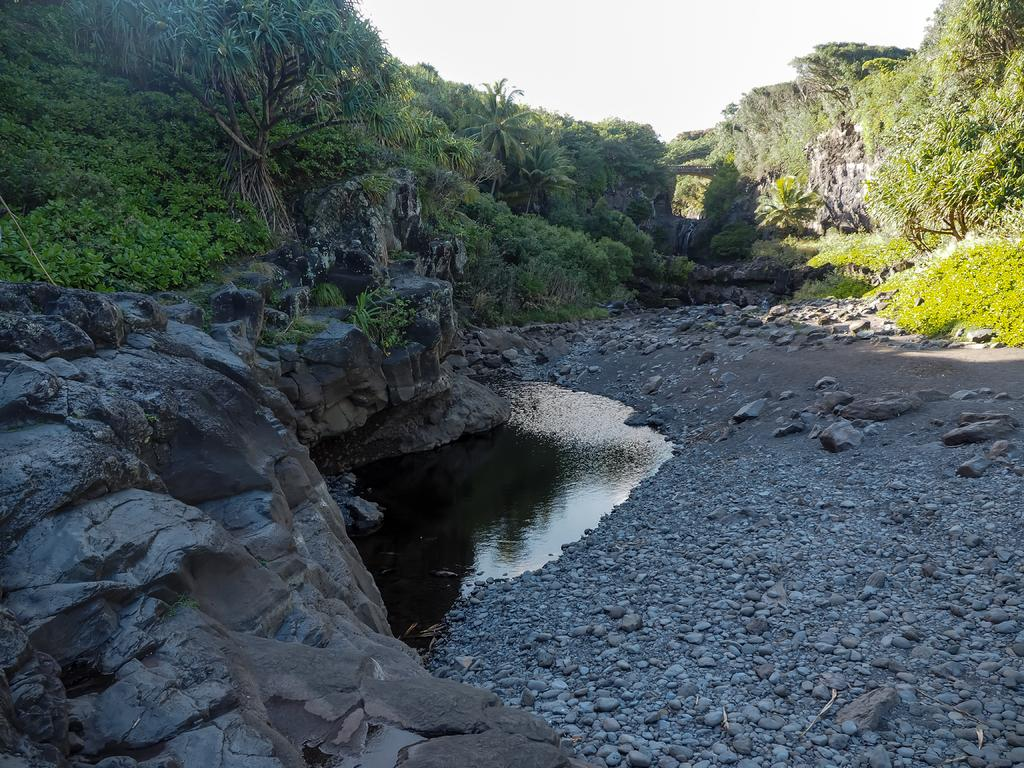What type of vegetation is present in the image? There are trees in the image. What other natural elements can be seen in the image? There are rocks and grass visible in the image. What is the water element in the image? There is water visible in the image. What part of the natural environment is visible in the background of the image? The sky is visible in the background of the image. How many chairs are visible in the image? There are no chairs present in the image. What type of wire can be seen connecting the trees in the image? There is no wire connecting the trees in the image; there are only trees, rocks, water, grass, and the sky visible. 